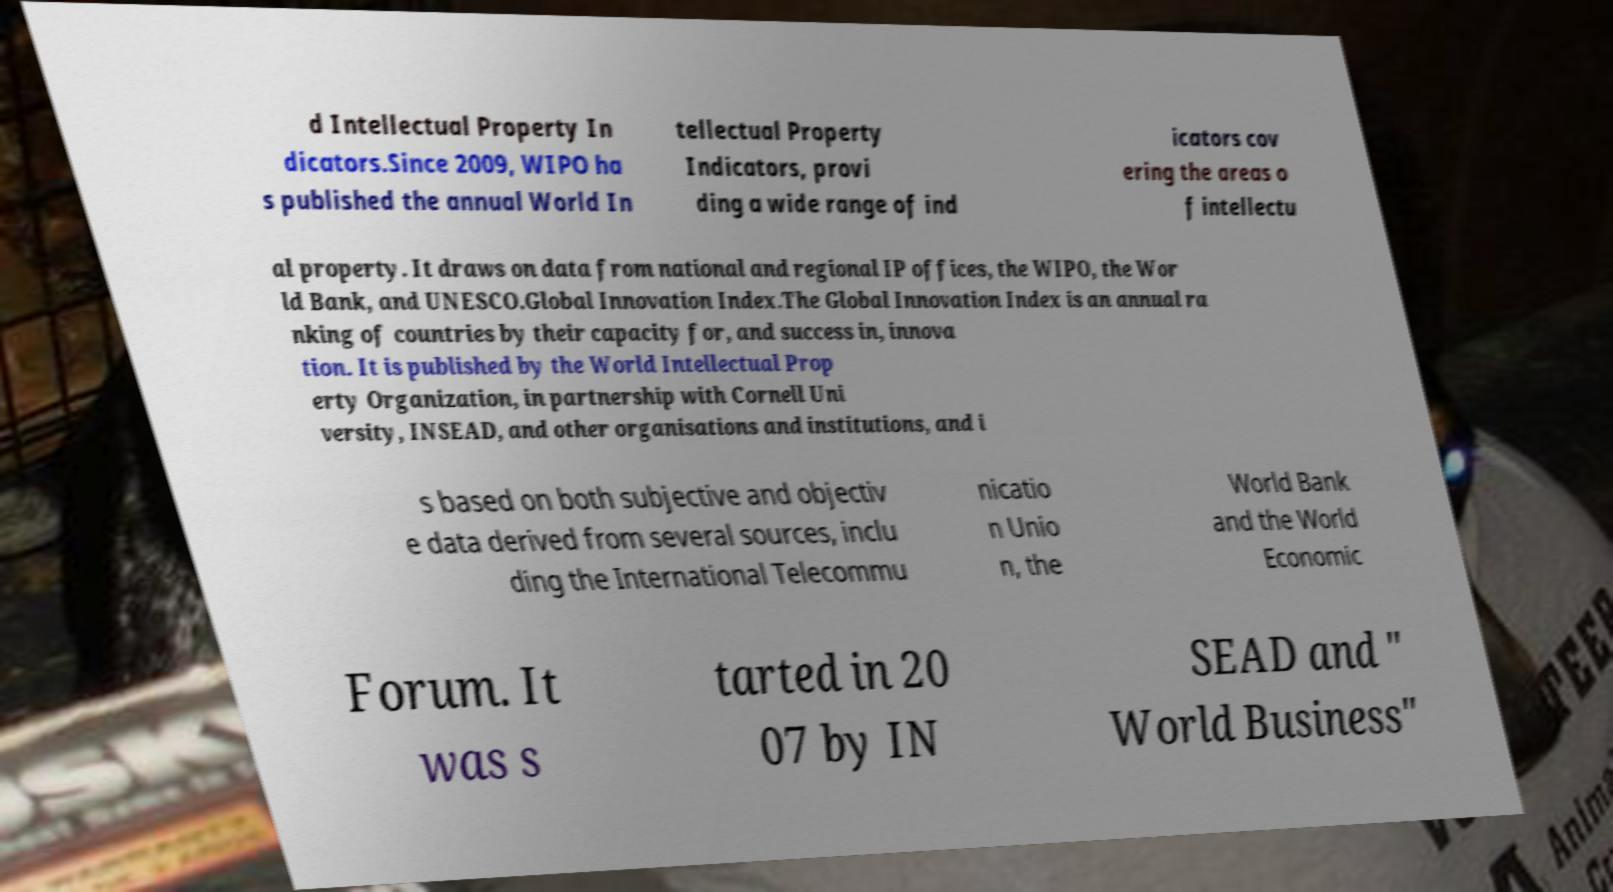Can you read and provide the text displayed in the image?This photo seems to have some interesting text. Can you extract and type it out for me? d Intellectual Property In dicators.Since 2009, WIPO ha s published the annual World In tellectual Property Indicators, provi ding a wide range of ind icators cov ering the areas o f intellectu al property. It draws on data from national and regional IP offices, the WIPO, the Wor ld Bank, and UNESCO.Global Innovation Index.The Global Innovation Index is an annual ra nking of countries by their capacity for, and success in, innova tion. It is published by the World Intellectual Prop erty Organization, in partnership with Cornell Uni versity, INSEAD, and other organisations and institutions, and i s based on both subjective and objectiv e data derived from several sources, inclu ding the International Telecommu nicatio n Unio n, the World Bank and the World Economic Forum. It was s tarted in 20 07 by IN SEAD and " World Business" 